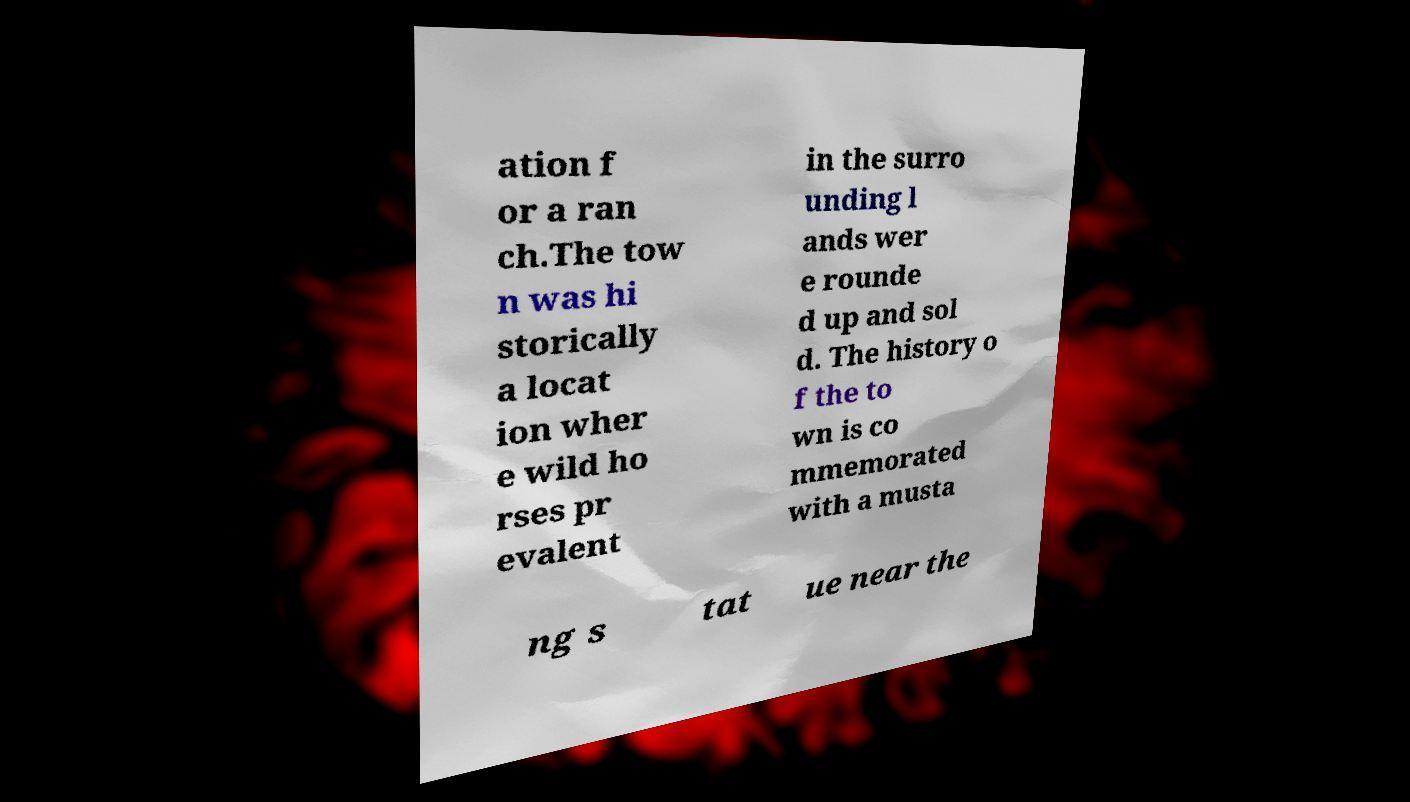I need the written content from this picture converted into text. Can you do that? ation f or a ran ch.The tow n was hi storically a locat ion wher e wild ho rses pr evalent in the surro unding l ands wer e rounde d up and sol d. The history o f the to wn is co mmemorated with a musta ng s tat ue near the 